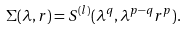Convert formula to latex. <formula><loc_0><loc_0><loc_500><loc_500>\Sigma ( \lambda , r ) = S ^ { ( l ) } ( \lambda ^ { q } , \lambda ^ { p - q } r ^ { p } ) .</formula> 